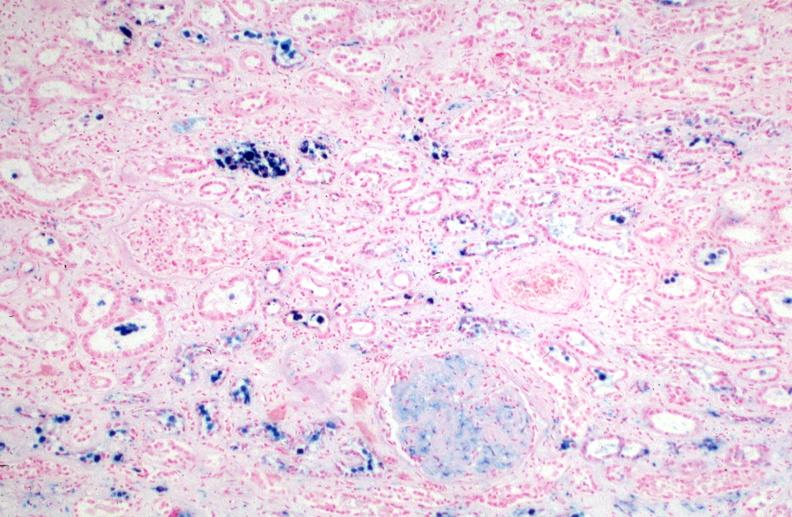how is hemosiderosis caused by blood transfusions.prusian blue?
Answer the question using a single word or phrase. Numerous 